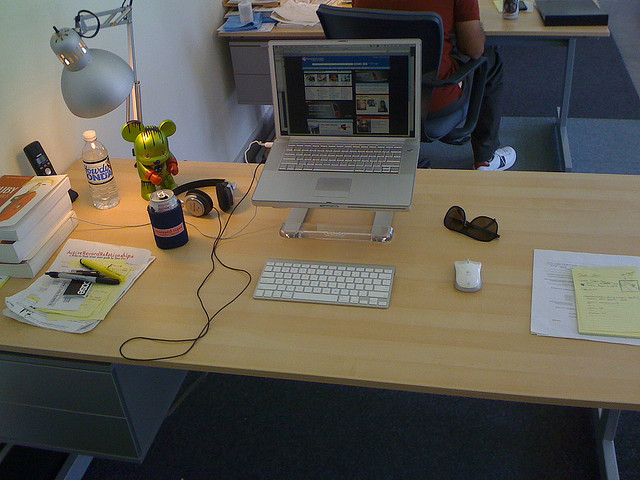<image>What brand is the keyboard? I don't know what brand is the keyboard. It could be asus, apple, dell, mac, or hp. What does the paper on the left side say at top? It's unclear what the paper on the left side says at the top. It might say 'active record relationships' or 'to do list', but it's not readable in the image. What brand is the keyboard? I am not sure what brand is the keyboard. It can be Asus, Apple, Dell, HP, or any other brand. What does the paper on the left side say at top? I don't know what the paper on the left side says at the top. It is unknown and cannot be read. 